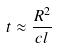Convert formula to latex. <formula><loc_0><loc_0><loc_500><loc_500>t \approx \frac { R ^ { 2 } } { c l }</formula> 